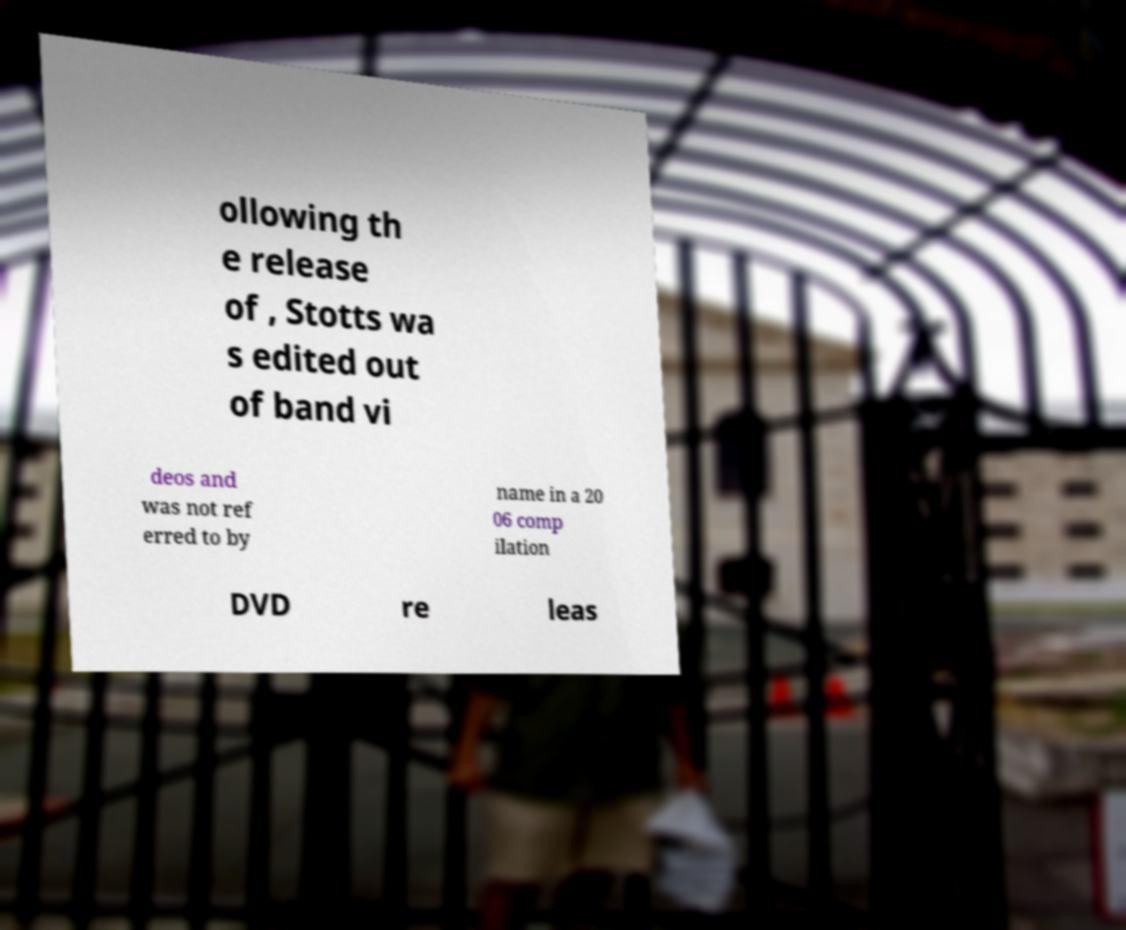Can you accurately transcribe the text from the provided image for me? ollowing th e release of , Stotts wa s edited out of band vi deos and was not ref erred to by name in a 20 06 comp ilation DVD re leas 